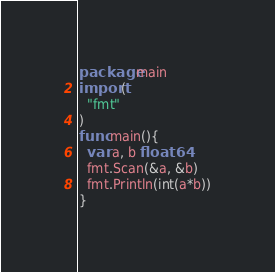<code> <loc_0><loc_0><loc_500><loc_500><_Go_>package main
import(
  "fmt"
)
func main(){
  var a, b float64
  fmt.Scan(&a, &b)
  fmt.Println(int(a*b))
}
</code> 